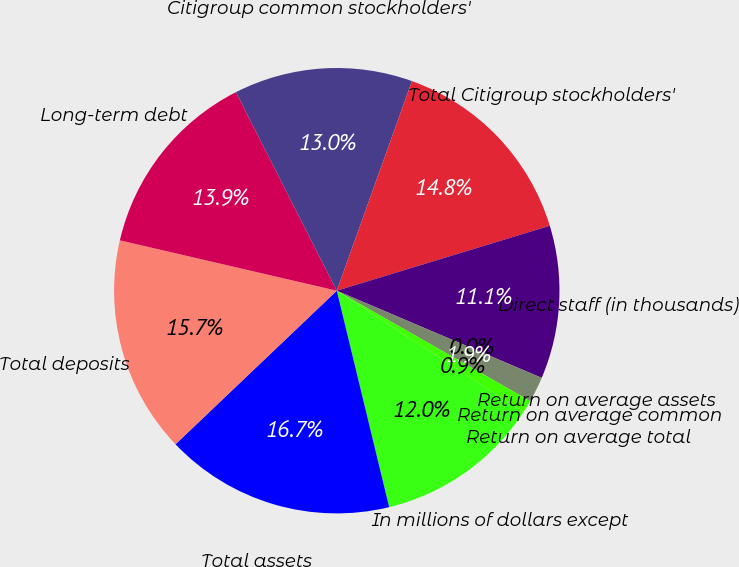Convert chart. <chart><loc_0><loc_0><loc_500><loc_500><pie_chart><fcel>In millions of dollars except<fcel>Total assets<fcel>Total deposits<fcel>Long-term debt<fcel>Citigroup common stockholders'<fcel>Total Citigroup stockholders'<fcel>Direct staff (in thousands)<fcel>Return on average assets<fcel>Return on average common<fcel>Return on average total<nl><fcel>12.04%<fcel>16.67%<fcel>15.74%<fcel>13.89%<fcel>12.96%<fcel>14.81%<fcel>11.11%<fcel>0.0%<fcel>1.85%<fcel>0.93%<nl></chart> 